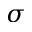Convert formula to latex. <formula><loc_0><loc_0><loc_500><loc_500>\sigma</formula> 